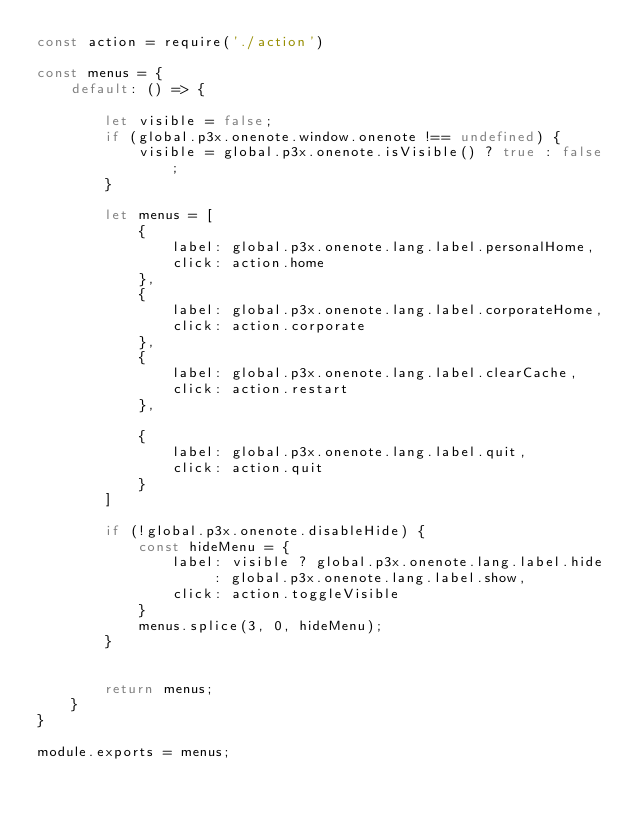Convert code to text. <code><loc_0><loc_0><loc_500><loc_500><_JavaScript_>const action = require('./action')

const menus = {
    default: () => {

        let visible = false;
        if (global.p3x.onenote.window.onenote !== undefined) {
            visible = global.p3x.onenote.isVisible() ? true : false;
        }

        let menus = [
            {
                label: global.p3x.onenote.lang.label.personalHome,
                click: action.home
            },
            {
                label: global.p3x.onenote.lang.label.corporateHome,
                click: action.corporate
            },
            {
                label: global.p3x.onenote.lang.label.clearCache,
                click: action.restart
            },

            {
                label: global.p3x.onenote.lang.label.quit,
                click: action.quit
            }
        ]

        if (!global.p3x.onenote.disableHide) {
            const hideMenu = {
                label: visible ? global.p3x.onenote.lang.label.hide : global.p3x.onenote.lang.label.show,
                click: action.toggleVisible
            }
            menus.splice(3, 0, hideMenu);
        }


        return menus;
    }
}

module.exports = menus;
</code> 